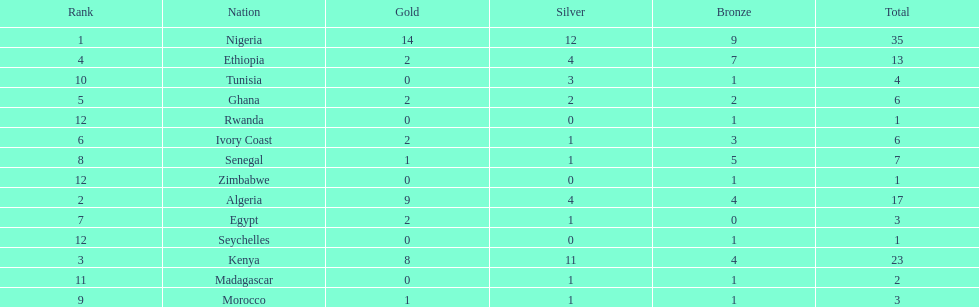Which country had the least bronze medals? Egypt. 